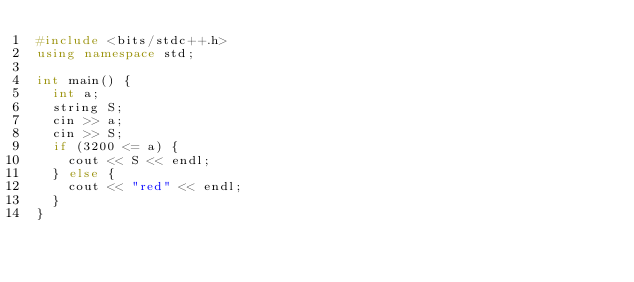<code> <loc_0><loc_0><loc_500><loc_500><_C++_>#include <bits/stdc++.h>
using namespace std;

int main() {
  int a;
  string S;
  cin >> a;
  cin >> S;
  if (3200 <= a) {
    cout << S << endl;
  } else {
    cout << "red" << endl;
  }
}</code> 